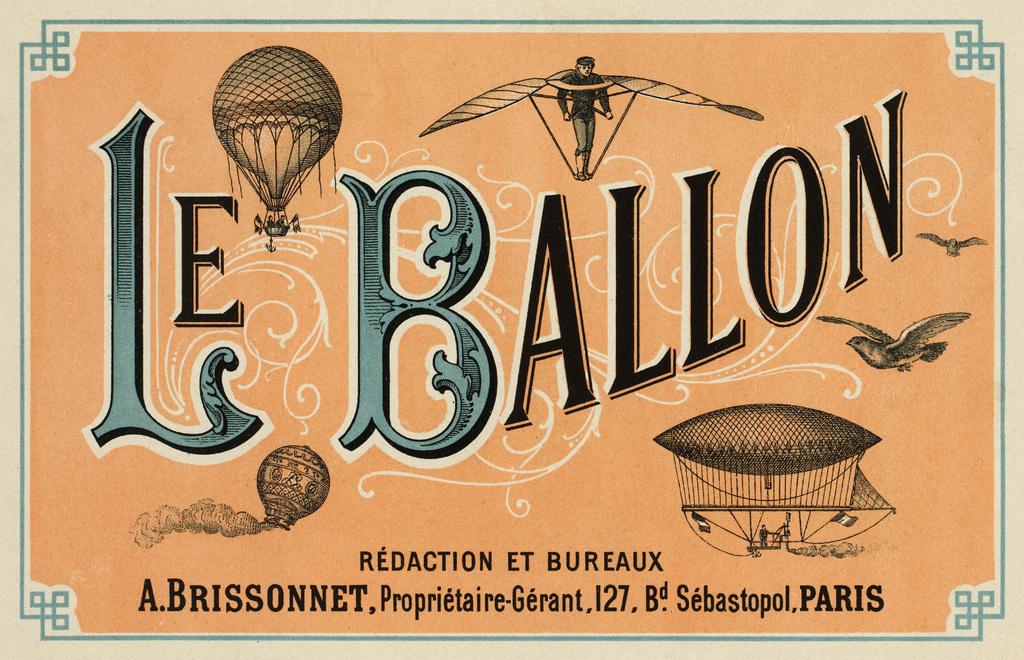What does the ad say?
Your answer should be compact. Le ballon. What city is mentioned?
Give a very brief answer. Paris. 